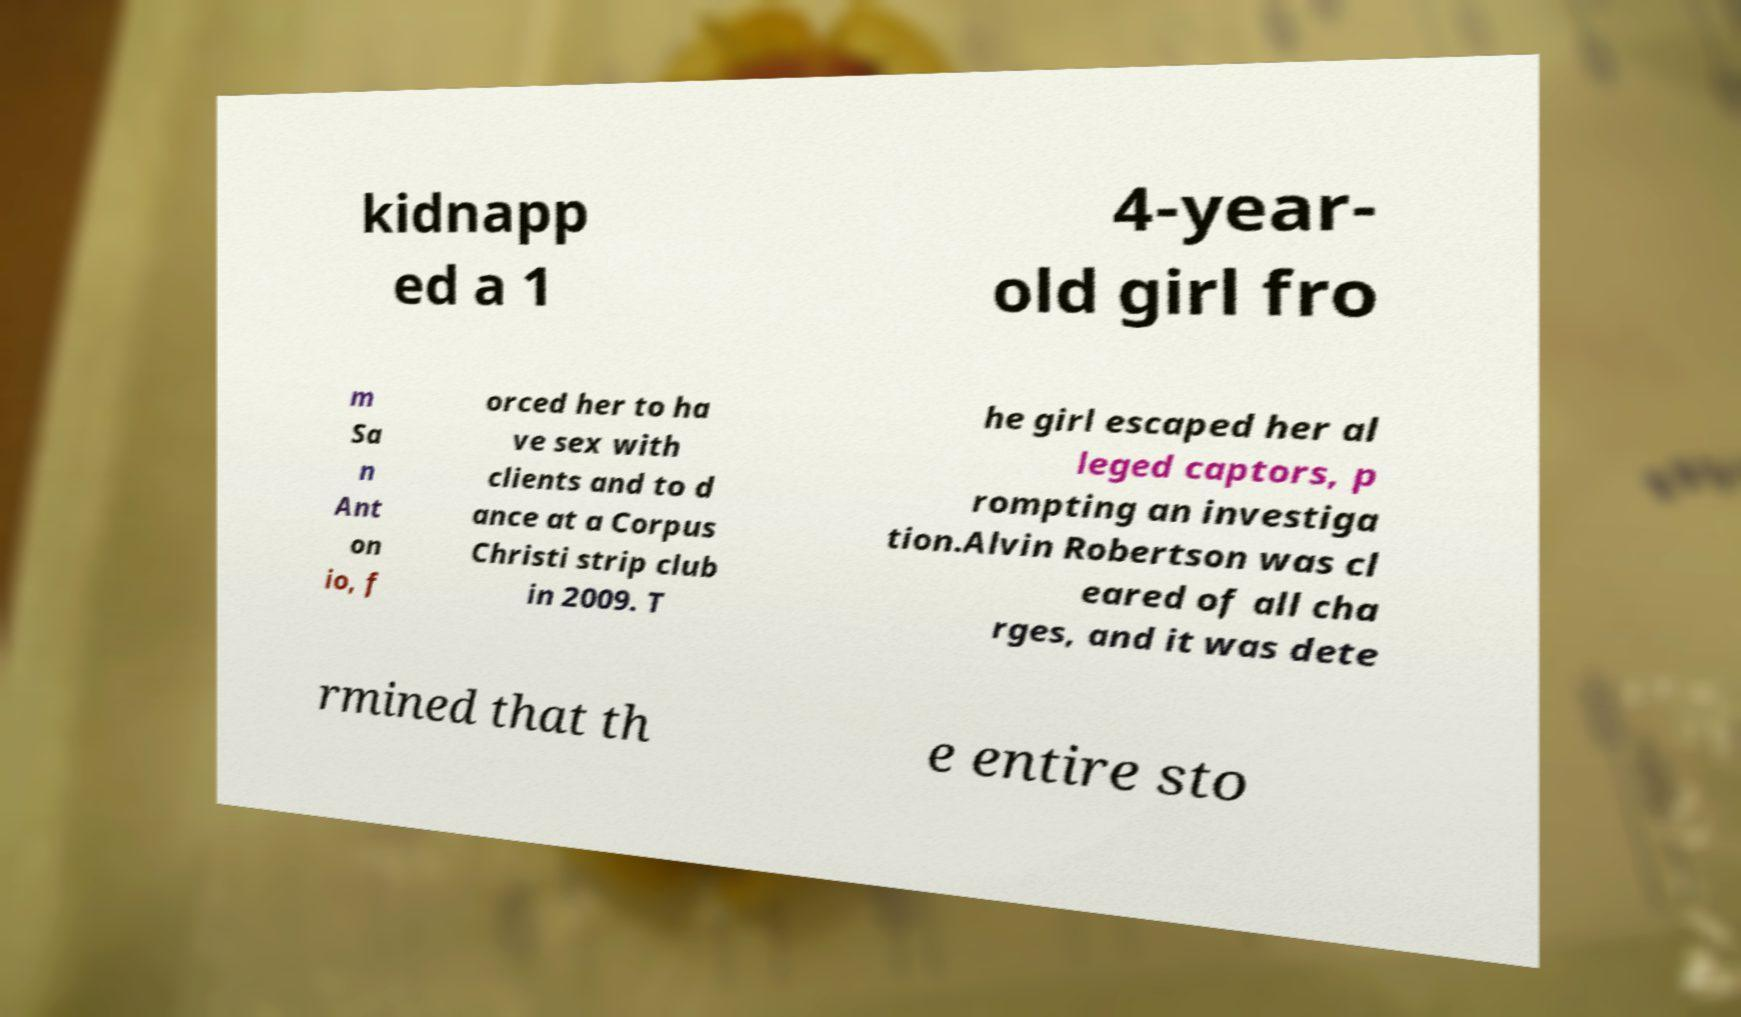Can you read and provide the text displayed in the image?This photo seems to have some interesting text. Can you extract and type it out for me? kidnapp ed a 1 4-year- old girl fro m Sa n Ant on io, f orced her to ha ve sex with clients and to d ance at a Corpus Christi strip club in 2009. T he girl escaped her al leged captors, p rompting an investiga tion.Alvin Robertson was cl eared of all cha rges, and it was dete rmined that th e entire sto 